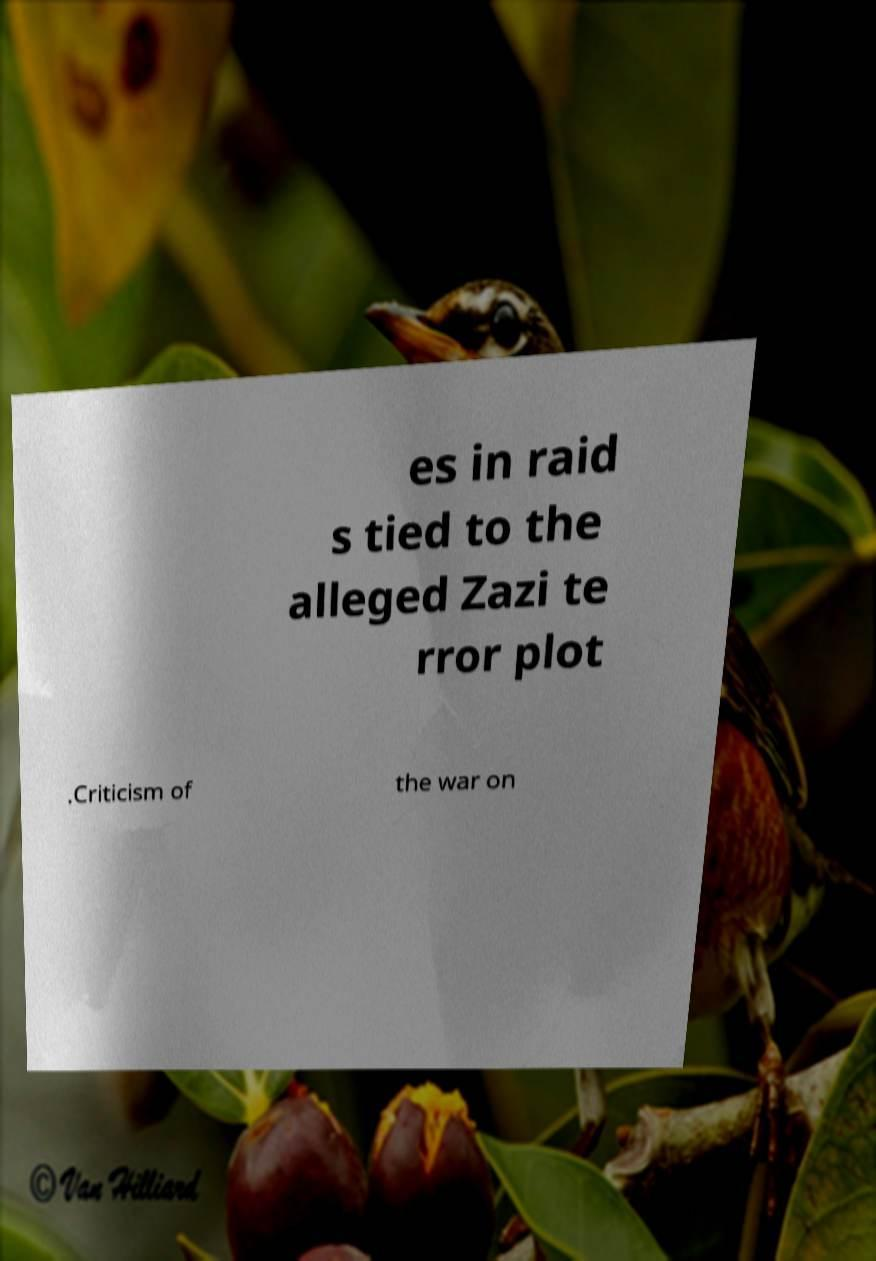Please read and relay the text visible in this image. What does it say? es in raid s tied to the alleged Zazi te rror plot .Criticism of the war on 